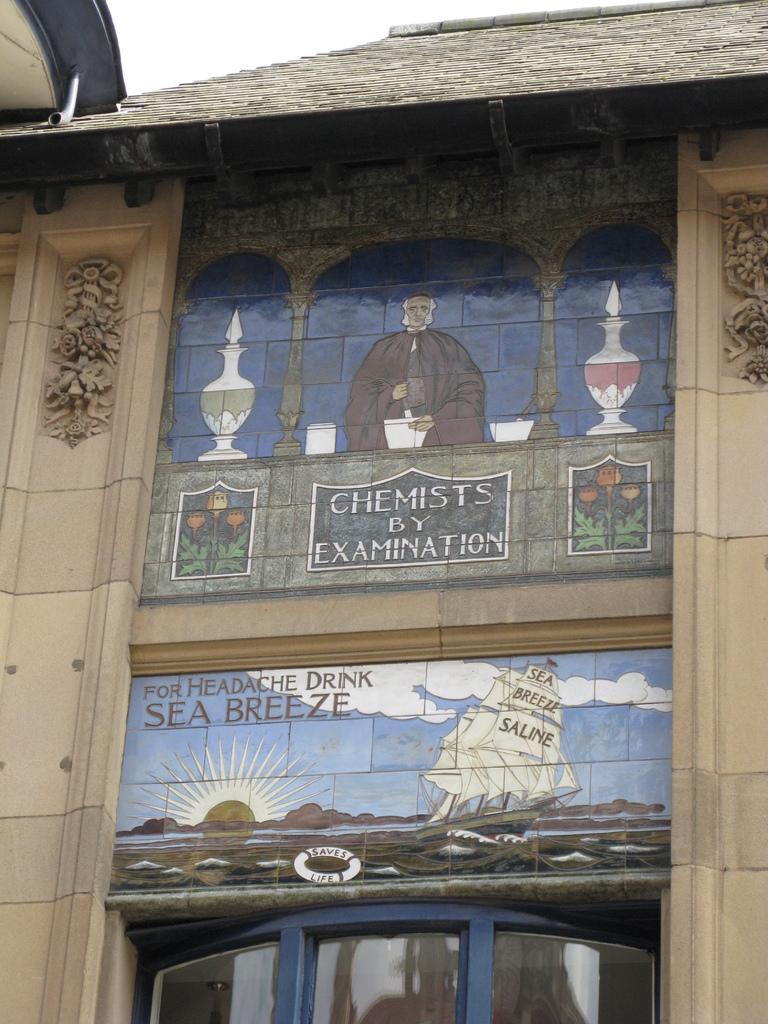Could you give a brief overview of what you see in this image? In this picture I can see there is a building and it has a picture of a man and there is something written on it. The sky is clear. 